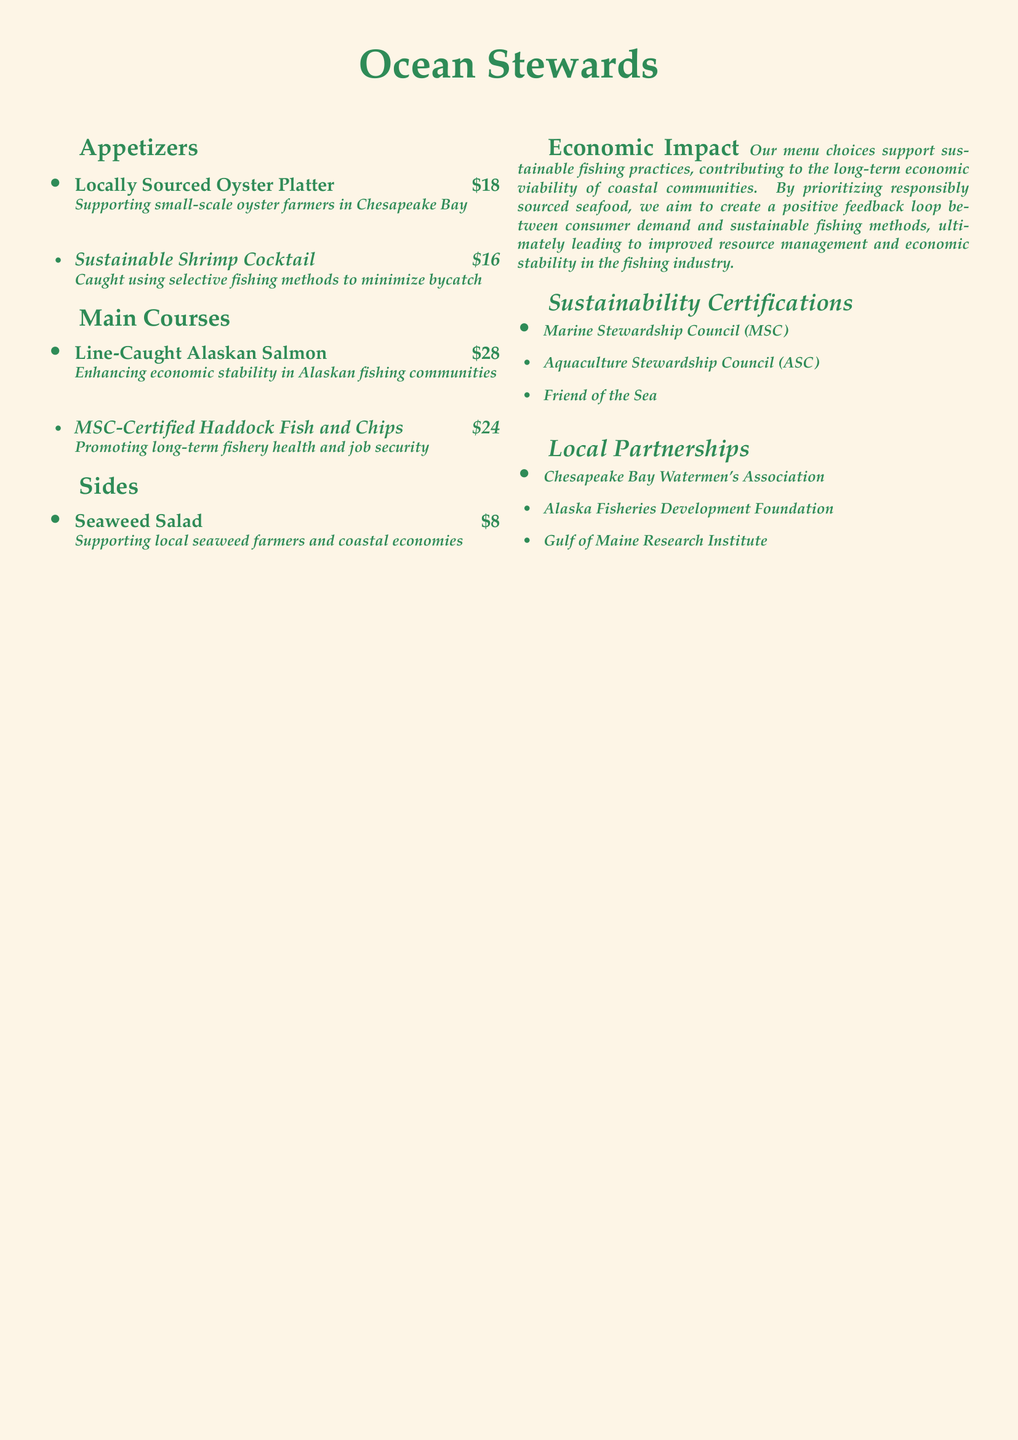What is the name of the restaurant? The restaurant is named "Ocean Stewards," as indicated at the top of the menu.
Answer: Ocean Stewards What is the price of the Locally Sourced Oyster Platter? The price listed for the Locally Sourced Oyster Platter is $18.
Answer: $18 Which seafood is MSC-Certified? The menu states that the Haddock Fish and Chips is MSC-Certified.
Answer: Haddock Fish and Chips What is the economic impact of the menu choices? The document mentions that the menu choices support sustainable fishing practices and contribute to the long-term economic viability of coastal communities.
Answer: Long-term economic viability Who does the restaurant partner with for local sustainability? The menu lists the Chesapeake Bay Watermen's Association as one of the local partnerships.
Answer: Chesapeake Bay Watermen's Association What method is used to catch the Sustainable Shrimp Cocktail? The Sustainable Shrimp Cocktail is caught using selective fishing methods, as noted in the description.
Answer: Selective fishing methods How much does the Seaweed Salad cost? The Seaweed Salad is priced at $8, as mentioned in the menu.
Answer: $8 What certification does the restaurant adhere to for aquaculture? The Aquaculture Stewardship Council is mentioned as one of the sustainability certifications.
Answer: Aquaculture Stewardship Council 